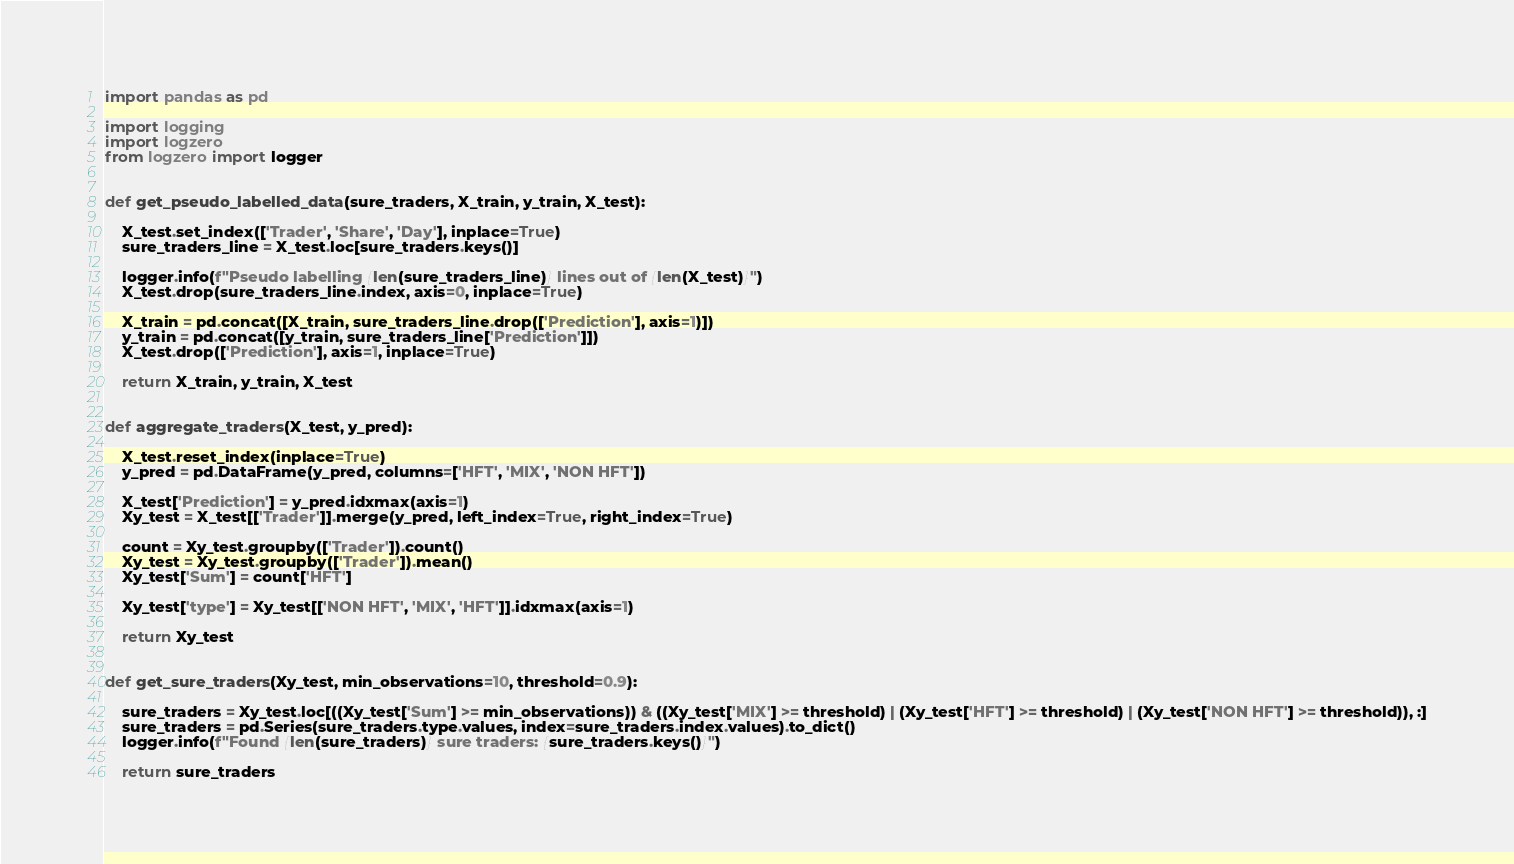Convert code to text. <code><loc_0><loc_0><loc_500><loc_500><_Python_>import pandas as pd

import logging
import logzero
from logzero import logger


def get_pseudo_labelled_data(sure_traders, X_train, y_train, X_test):

    X_test.set_index(['Trader', 'Share', 'Day'], inplace=True)
    sure_traders_line = X_test.loc[sure_traders.keys()]

    logger.info(f"Pseudo labelling {len(sure_traders_line)} lines out of {len(X_test)}")
    X_test.drop(sure_traders_line.index, axis=0, inplace=True)

    X_train = pd.concat([X_train, sure_traders_line.drop(['Prediction'], axis=1)])
    y_train = pd.concat([y_train, sure_traders_line['Prediction']])
    X_test.drop(['Prediction'], axis=1, inplace=True)

    return X_train, y_train, X_test


def aggregate_traders(X_test, y_pred):

    X_test.reset_index(inplace=True)
    y_pred = pd.DataFrame(y_pred, columns=['HFT', 'MIX', 'NON HFT'])

    X_test['Prediction'] = y_pred.idxmax(axis=1)
    Xy_test = X_test[['Trader']].merge(y_pred, left_index=True, right_index=True)

    count = Xy_test.groupby(['Trader']).count()
    Xy_test = Xy_test.groupby(['Trader']).mean()    
    Xy_test['Sum'] = count['HFT']

    Xy_test['type'] = Xy_test[['NON HFT', 'MIX', 'HFT']].idxmax(axis=1)

    return Xy_test


def get_sure_traders(Xy_test, min_observations=10, threshold=0.9):

    sure_traders = Xy_test.loc[((Xy_test['Sum'] >= min_observations)) & ((Xy_test['MIX'] >= threshold) | (Xy_test['HFT'] >= threshold) | (Xy_test['NON HFT'] >= threshold)), :]
    sure_traders = pd.Series(sure_traders.type.values, index=sure_traders.index.values).to_dict()
    logger.info(f"Found {len(sure_traders)} sure traders: {sure_traders.keys()}")

    return sure_traders
</code> 